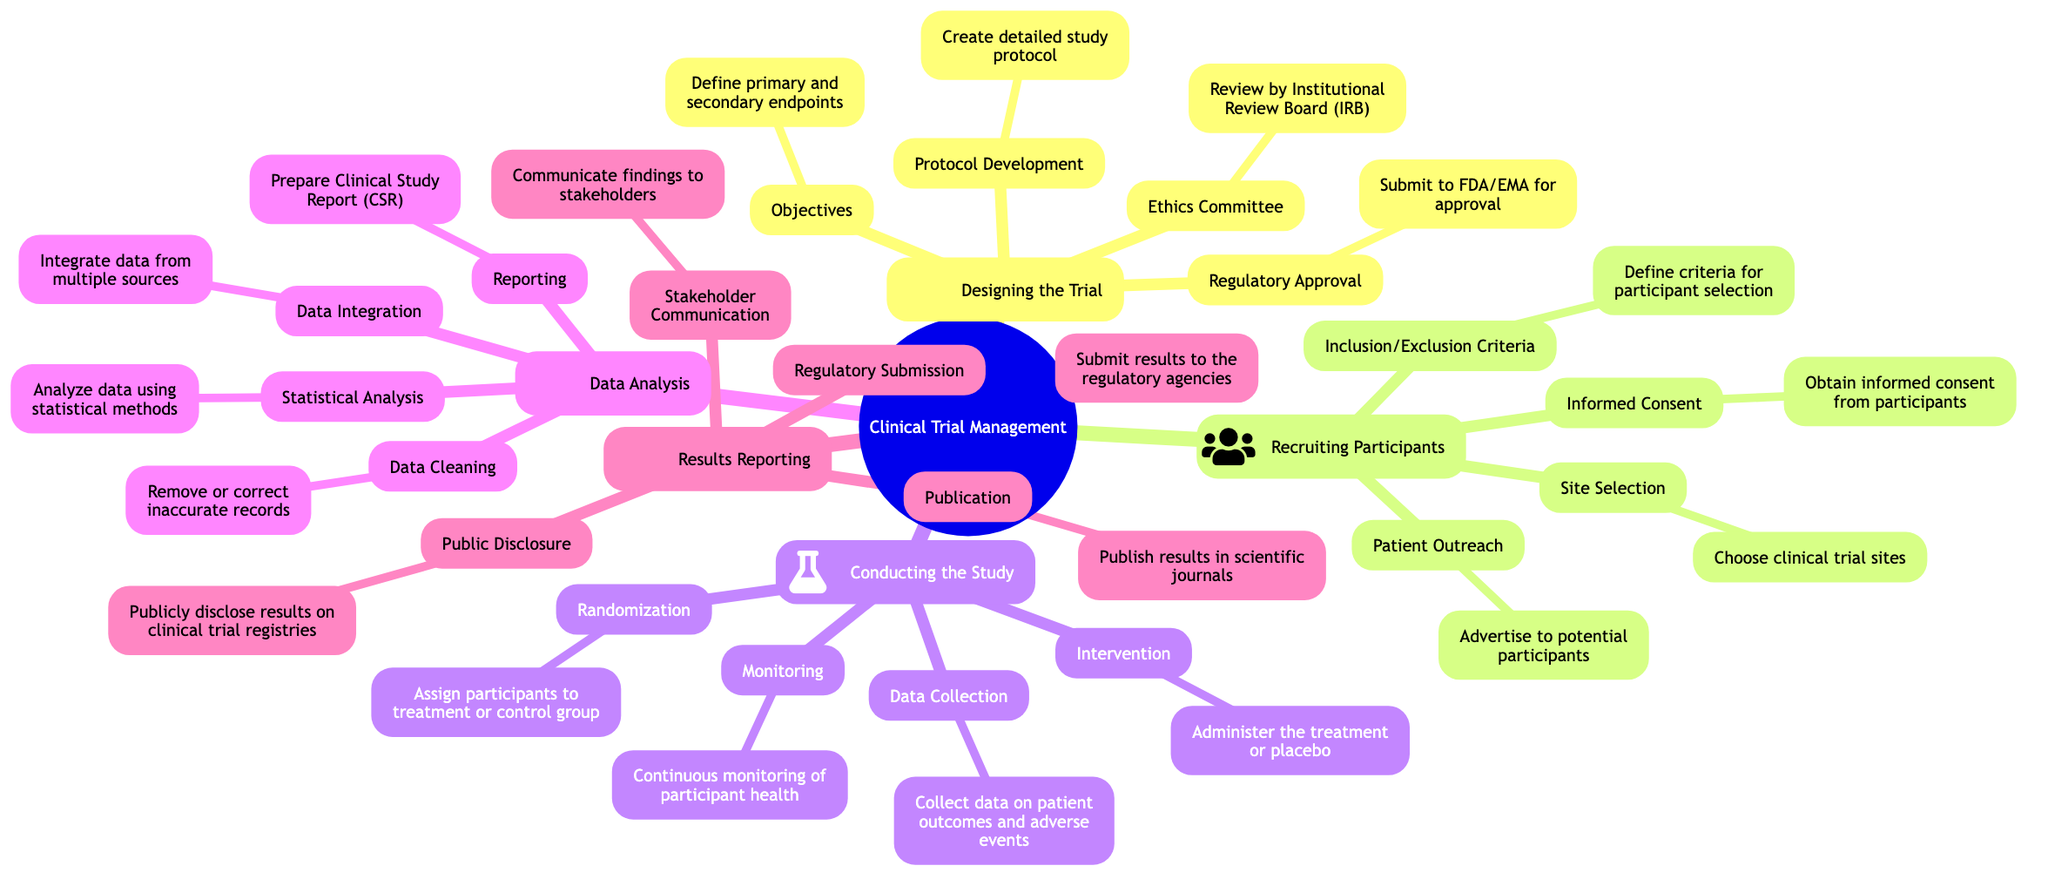What are the four main phases of clinical trial management? The four main phases displayed in the mind map are Designing the Trial, Recruiting Participants, Conducting the Study, and Data Analysis.
Answer: Designing the Trial, Recruiting Participants, Conducting the Study, Data Analysis What is one objective of designing a clinical trial? An objective of designing a clinical trial is to define primary and secondary endpoints. This task is specifically highlighted under the Designing the Trial phase in the diagram.
Answer: Define primary and secondary endpoints Which phase involves obtaining informed consent? Obtaining informed consent is listed as a procedure within the Recruiting Participants phase of the diagram. It indicates that participants must agree to participate after being informed about the trial.
Answer: Recruiting Participants How many criteria are specified for recruiting participants? There are four criteria specified under the Recruiting Participants section: Inclusion/Exclusion Criteria, Site Selection, Patient Outreach, and Informed Consent. This totals to four distinct criteria.
Answer: Four What is the first step in the Data Analysis phase? The first step in the Data Analysis phase is Data Cleaning, which involves removing or correcting inaccurate records. This step is crucial for ensuring the quality of the data before further analysis.
Answer: Data Cleaning Which regulatory agency is mentioned for approval during the trial design? The FDA (Food and Drug Administration) is mentioned as one of the regulatory agencies for obtaining approval during the trial design phase in the diagram.
Answer: FDA What type of results are published in scientific journals? Results from the clinical trials are published in scientific journals, indicating the findings and impacts of the research conducted during the trials. This is categorized under the Results Reporting phase.
Answer: Results What is the purpose of the Ethics Committee in the clinical trial process? The Ethics Committee, specifically the Institutional Review Board (IRB), is responsible for reviewing the trial's ethics to ensure participant safety and ethical standards. This is part of the Designing the Trial phase.
Answer: Review by Institutional Review Board (IRB) What does the term "Randomization" refer to in this context? Randomization refers to the process of assigning participants to treatment or control groups, ensuring unbiased results in clinical trials. This is listed as a part of the Conducting the Study phase.
Answer: Assign participants to treatment or control group 